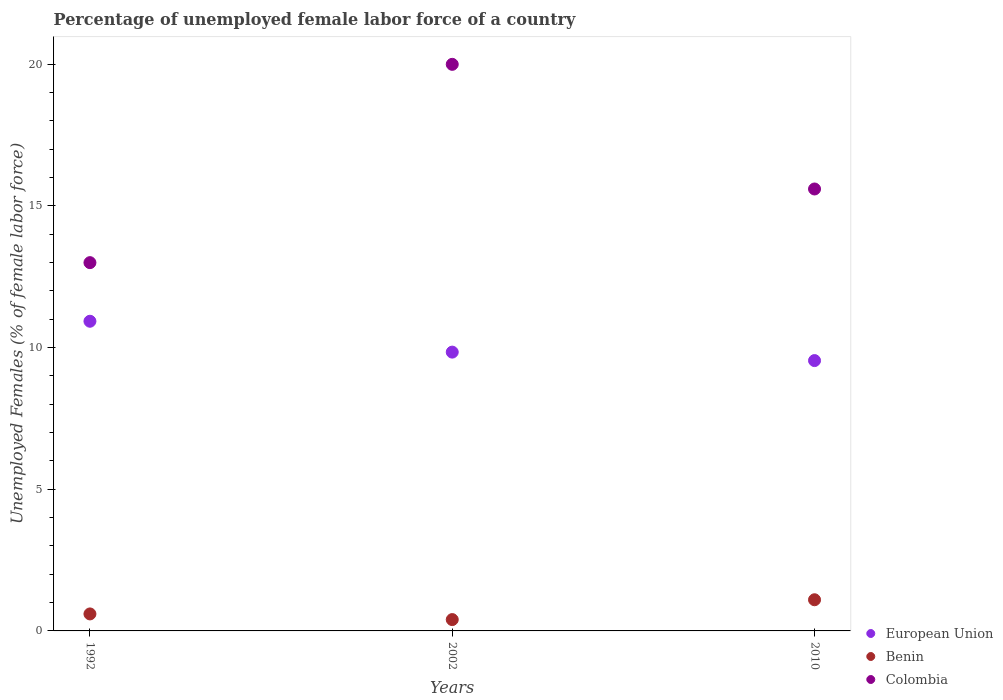Is the number of dotlines equal to the number of legend labels?
Keep it short and to the point. Yes. What is the percentage of unemployed female labor force in Benin in 2002?
Offer a very short reply. 0.4. Across all years, what is the maximum percentage of unemployed female labor force in European Union?
Provide a succinct answer. 10.93. Across all years, what is the minimum percentage of unemployed female labor force in Colombia?
Your answer should be compact. 13. What is the total percentage of unemployed female labor force in Colombia in the graph?
Ensure brevity in your answer.  48.6. What is the difference between the percentage of unemployed female labor force in Benin in 2002 and that in 2010?
Offer a terse response. -0.7. What is the difference between the percentage of unemployed female labor force in Benin in 2002 and the percentage of unemployed female labor force in Colombia in 1992?
Ensure brevity in your answer.  -12.6. What is the average percentage of unemployed female labor force in Benin per year?
Provide a short and direct response. 0.7. In the year 2002, what is the difference between the percentage of unemployed female labor force in European Union and percentage of unemployed female labor force in Benin?
Give a very brief answer. 9.44. What is the ratio of the percentage of unemployed female labor force in Benin in 1992 to that in 2002?
Offer a terse response. 1.5. What is the difference between the highest and the second highest percentage of unemployed female labor force in Benin?
Your answer should be compact. 0.5. What is the difference between the highest and the lowest percentage of unemployed female labor force in Benin?
Offer a very short reply. 0.7. In how many years, is the percentage of unemployed female labor force in Benin greater than the average percentage of unemployed female labor force in Benin taken over all years?
Offer a terse response. 1. Is it the case that in every year, the sum of the percentage of unemployed female labor force in European Union and percentage of unemployed female labor force in Colombia  is greater than the percentage of unemployed female labor force in Benin?
Provide a succinct answer. Yes. Is the percentage of unemployed female labor force in European Union strictly greater than the percentage of unemployed female labor force in Benin over the years?
Give a very brief answer. Yes. Is the percentage of unemployed female labor force in European Union strictly less than the percentage of unemployed female labor force in Benin over the years?
Your response must be concise. No. How many years are there in the graph?
Your response must be concise. 3. What is the difference between two consecutive major ticks on the Y-axis?
Make the answer very short. 5. Are the values on the major ticks of Y-axis written in scientific E-notation?
Make the answer very short. No. Does the graph contain any zero values?
Your answer should be compact. No. Does the graph contain grids?
Offer a terse response. No. Where does the legend appear in the graph?
Offer a very short reply. Bottom right. How many legend labels are there?
Make the answer very short. 3. How are the legend labels stacked?
Keep it short and to the point. Vertical. What is the title of the graph?
Your answer should be very brief. Percentage of unemployed female labor force of a country. What is the label or title of the Y-axis?
Make the answer very short. Unemployed Females (% of female labor force). What is the Unemployed Females (% of female labor force) in European Union in 1992?
Your answer should be very brief. 10.93. What is the Unemployed Females (% of female labor force) in Benin in 1992?
Provide a succinct answer. 0.6. What is the Unemployed Females (% of female labor force) in Colombia in 1992?
Your answer should be very brief. 13. What is the Unemployed Females (% of female labor force) in European Union in 2002?
Your response must be concise. 9.84. What is the Unemployed Females (% of female labor force) in Benin in 2002?
Keep it short and to the point. 0.4. What is the Unemployed Females (% of female labor force) in Colombia in 2002?
Provide a succinct answer. 20. What is the Unemployed Females (% of female labor force) of European Union in 2010?
Your answer should be compact. 9.54. What is the Unemployed Females (% of female labor force) of Benin in 2010?
Make the answer very short. 1.1. What is the Unemployed Females (% of female labor force) in Colombia in 2010?
Offer a terse response. 15.6. Across all years, what is the maximum Unemployed Females (% of female labor force) in European Union?
Offer a very short reply. 10.93. Across all years, what is the maximum Unemployed Females (% of female labor force) in Benin?
Provide a short and direct response. 1.1. Across all years, what is the minimum Unemployed Females (% of female labor force) of European Union?
Make the answer very short. 9.54. Across all years, what is the minimum Unemployed Females (% of female labor force) of Benin?
Ensure brevity in your answer.  0.4. Across all years, what is the minimum Unemployed Females (% of female labor force) of Colombia?
Provide a short and direct response. 13. What is the total Unemployed Females (% of female labor force) in European Union in the graph?
Ensure brevity in your answer.  30.32. What is the total Unemployed Females (% of female labor force) of Benin in the graph?
Offer a terse response. 2.1. What is the total Unemployed Females (% of female labor force) of Colombia in the graph?
Provide a succinct answer. 48.6. What is the difference between the Unemployed Females (% of female labor force) of European Union in 1992 and that in 2002?
Provide a succinct answer. 1.09. What is the difference between the Unemployed Females (% of female labor force) of Colombia in 1992 and that in 2002?
Your response must be concise. -7. What is the difference between the Unemployed Females (% of female labor force) of European Union in 1992 and that in 2010?
Give a very brief answer. 1.39. What is the difference between the Unemployed Females (% of female labor force) in European Union in 2002 and that in 2010?
Ensure brevity in your answer.  0.3. What is the difference between the Unemployed Females (% of female labor force) of Benin in 2002 and that in 2010?
Your answer should be very brief. -0.7. What is the difference between the Unemployed Females (% of female labor force) in European Union in 1992 and the Unemployed Females (% of female labor force) in Benin in 2002?
Your answer should be very brief. 10.53. What is the difference between the Unemployed Females (% of female labor force) of European Union in 1992 and the Unemployed Females (% of female labor force) of Colombia in 2002?
Keep it short and to the point. -9.07. What is the difference between the Unemployed Females (% of female labor force) of Benin in 1992 and the Unemployed Females (% of female labor force) of Colombia in 2002?
Ensure brevity in your answer.  -19.4. What is the difference between the Unemployed Females (% of female labor force) in European Union in 1992 and the Unemployed Females (% of female labor force) in Benin in 2010?
Make the answer very short. 9.83. What is the difference between the Unemployed Females (% of female labor force) of European Union in 1992 and the Unemployed Females (% of female labor force) of Colombia in 2010?
Provide a succinct answer. -4.67. What is the difference between the Unemployed Females (% of female labor force) in Benin in 1992 and the Unemployed Females (% of female labor force) in Colombia in 2010?
Provide a short and direct response. -15. What is the difference between the Unemployed Females (% of female labor force) in European Union in 2002 and the Unemployed Females (% of female labor force) in Benin in 2010?
Keep it short and to the point. 8.74. What is the difference between the Unemployed Females (% of female labor force) in European Union in 2002 and the Unemployed Females (% of female labor force) in Colombia in 2010?
Provide a short and direct response. -5.76. What is the difference between the Unemployed Females (% of female labor force) in Benin in 2002 and the Unemployed Females (% of female labor force) in Colombia in 2010?
Offer a very short reply. -15.2. What is the average Unemployed Females (% of female labor force) in European Union per year?
Provide a short and direct response. 10.11. What is the average Unemployed Females (% of female labor force) in Colombia per year?
Provide a short and direct response. 16.2. In the year 1992, what is the difference between the Unemployed Females (% of female labor force) in European Union and Unemployed Females (% of female labor force) in Benin?
Make the answer very short. 10.33. In the year 1992, what is the difference between the Unemployed Females (% of female labor force) in European Union and Unemployed Females (% of female labor force) in Colombia?
Make the answer very short. -2.07. In the year 2002, what is the difference between the Unemployed Females (% of female labor force) of European Union and Unemployed Females (% of female labor force) of Benin?
Your answer should be compact. 9.44. In the year 2002, what is the difference between the Unemployed Females (% of female labor force) in European Union and Unemployed Females (% of female labor force) in Colombia?
Keep it short and to the point. -10.16. In the year 2002, what is the difference between the Unemployed Females (% of female labor force) of Benin and Unemployed Females (% of female labor force) of Colombia?
Your answer should be compact. -19.6. In the year 2010, what is the difference between the Unemployed Females (% of female labor force) in European Union and Unemployed Females (% of female labor force) in Benin?
Your answer should be compact. 8.44. In the year 2010, what is the difference between the Unemployed Females (% of female labor force) of European Union and Unemployed Females (% of female labor force) of Colombia?
Provide a succinct answer. -6.06. What is the ratio of the Unemployed Females (% of female labor force) of European Union in 1992 to that in 2002?
Give a very brief answer. 1.11. What is the ratio of the Unemployed Females (% of female labor force) in Colombia in 1992 to that in 2002?
Your answer should be very brief. 0.65. What is the ratio of the Unemployed Females (% of female labor force) of European Union in 1992 to that in 2010?
Your answer should be compact. 1.15. What is the ratio of the Unemployed Females (% of female labor force) in Benin in 1992 to that in 2010?
Your answer should be very brief. 0.55. What is the ratio of the Unemployed Females (% of female labor force) in Colombia in 1992 to that in 2010?
Your answer should be compact. 0.83. What is the ratio of the Unemployed Females (% of female labor force) of European Union in 2002 to that in 2010?
Your answer should be very brief. 1.03. What is the ratio of the Unemployed Females (% of female labor force) of Benin in 2002 to that in 2010?
Your answer should be very brief. 0.36. What is the ratio of the Unemployed Females (% of female labor force) of Colombia in 2002 to that in 2010?
Keep it short and to the point. 1.28. What is the difference between the highest and the second highest Unemployed Females (% of female labor force) in European Union?
Offer a very short reply. 1.09. What is the difference between the highest and the second highest Unemployed Females (% of female labor force) in Colombia?
Offer a very short reply. 4.4. What is the difference between the highest and the lowest Unemployed Females (% of female labor force) in European Union?
Your answer should be compact. 1.39. What is the difference between the highest and the lowest Unemployed Females (% of female labor force) in Colombia?
Provide a short and direct response. 7. 